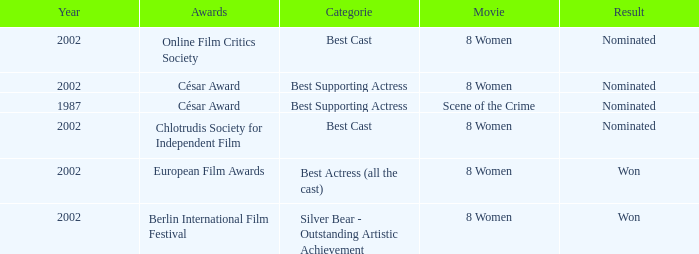Can you give me this table as a dict? {'header': ['Year', 'Awards', 'Categorie', 'Movie', 'Result'], 'rows': [['2002', 'Online Film Critics Society', 'Best Cast', '8 Women', 'Nominated'], ['2002', 'César Award', 'Best Supporting Actress', '8 Women', 'Nominated'], ['1987', 'César Award', 'Best Supporting Actress', 'Scene of the Crime', 'Nominated'], ['2002', 'Chlotrudis Society for Independent Film', 'Best Cast', '8 Women', 'Nominated'], ['2002', 'European Film Awards', 'Best Actress (all the cast)', '8 Women', 'Won'], ['2002', 'Berlin International Film Festival', 'Silver Bear - Outstanding Artistic Achievement', '8 Women', 'Won']]} What was the categorie in 2002 at the Berlin international Film Festival that Danielle Darrieux was in? Silver Bear - Outstanding Artistic Achievement. 